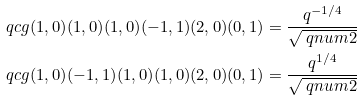<formula> <loc_0><loc_0><loc_500><loc_500>\ q c g { ( 1 , 0 ) } { ( 1 , 0 ) } { ( 1 , 0 ) } { ( - 1 , 1 ) } { ( 2 , 0 ) } { ( 0 , 1 ) } & = \frac { q ^ { - 1 / 4 } } { \sqrt { \ q n u m { 2 } } } \\ \ q c g { ( 1 , 0 ) } { ( - 1 , 1 ) } { ( 1 , 0 ) } { ( 1 , 0 ) } { ( 2 , 0 ) } { ( 0 , 1 ) } & = \frac { q ^ { 1 / 4 } } { \sqrt { \ q n u m { 2 } } }</formula> 